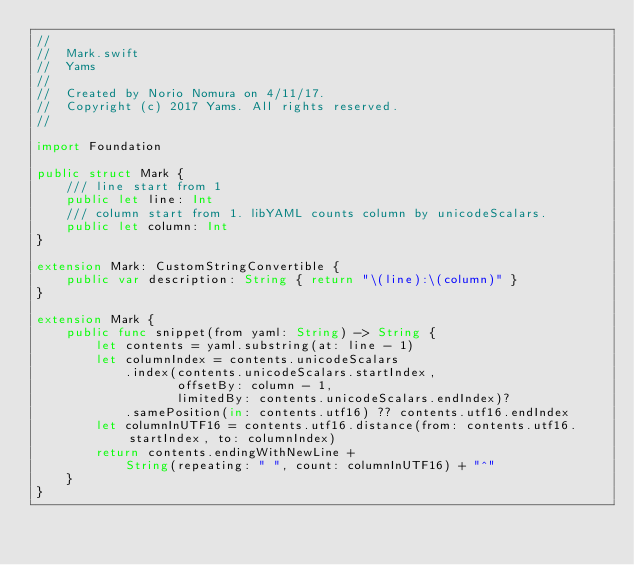<code> <loc_0><loc_0><loc_500><loc_500><_Swift_>//
//  Mark.swift
//  Yams
//
//  Created by Norio Nomura on 4/11/17.
//  Copyright (c) 2017 Yams. All rights reserved.
//

import Foundation

public struct Mark {
    /// line start from 1
    public let line: Int
    /// column start from 1. libYAML counts column by unicodeScalars.
    public let column: Int
}

extension Mark: CustomStringConvertible {
    public var description: String { return "\(line):\(column)" }
}

extension Mark {
    public func snippet(from yaml: String) -> String {
        let contents = yaml.substring(at: line - 1)
        let columnIndex = contents.unicodeScalars
            .index(contents.unicodeScalars.startIndex,
                   offsetBy: column - 1,
                   limitedBy: contents.unicodeScalars.endIndex)?
            .samePosition(in: contents.utf16) ?? contents.utf16.endIndex
        let columnInUTF16 = contents.utf16.distance(from: contents.utf16.startIndex, to: columnIndex)
        return contents.endingWithNewLine +
            String(repeating: " ", count: columnInUTF16) + "^"
    }
}
</code> 